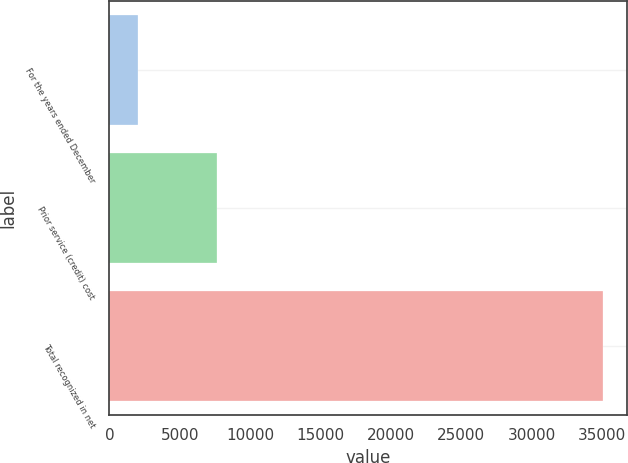<chart> <loc_0><loc_0><loc_500><loc_500><bar_chart><fcel>For the years ended December<fcel>Prior service (credit) cost<fcel>Total recognized in net<nl><fcel>2011<fcel>7614<fcel>35048<nl></chart> 